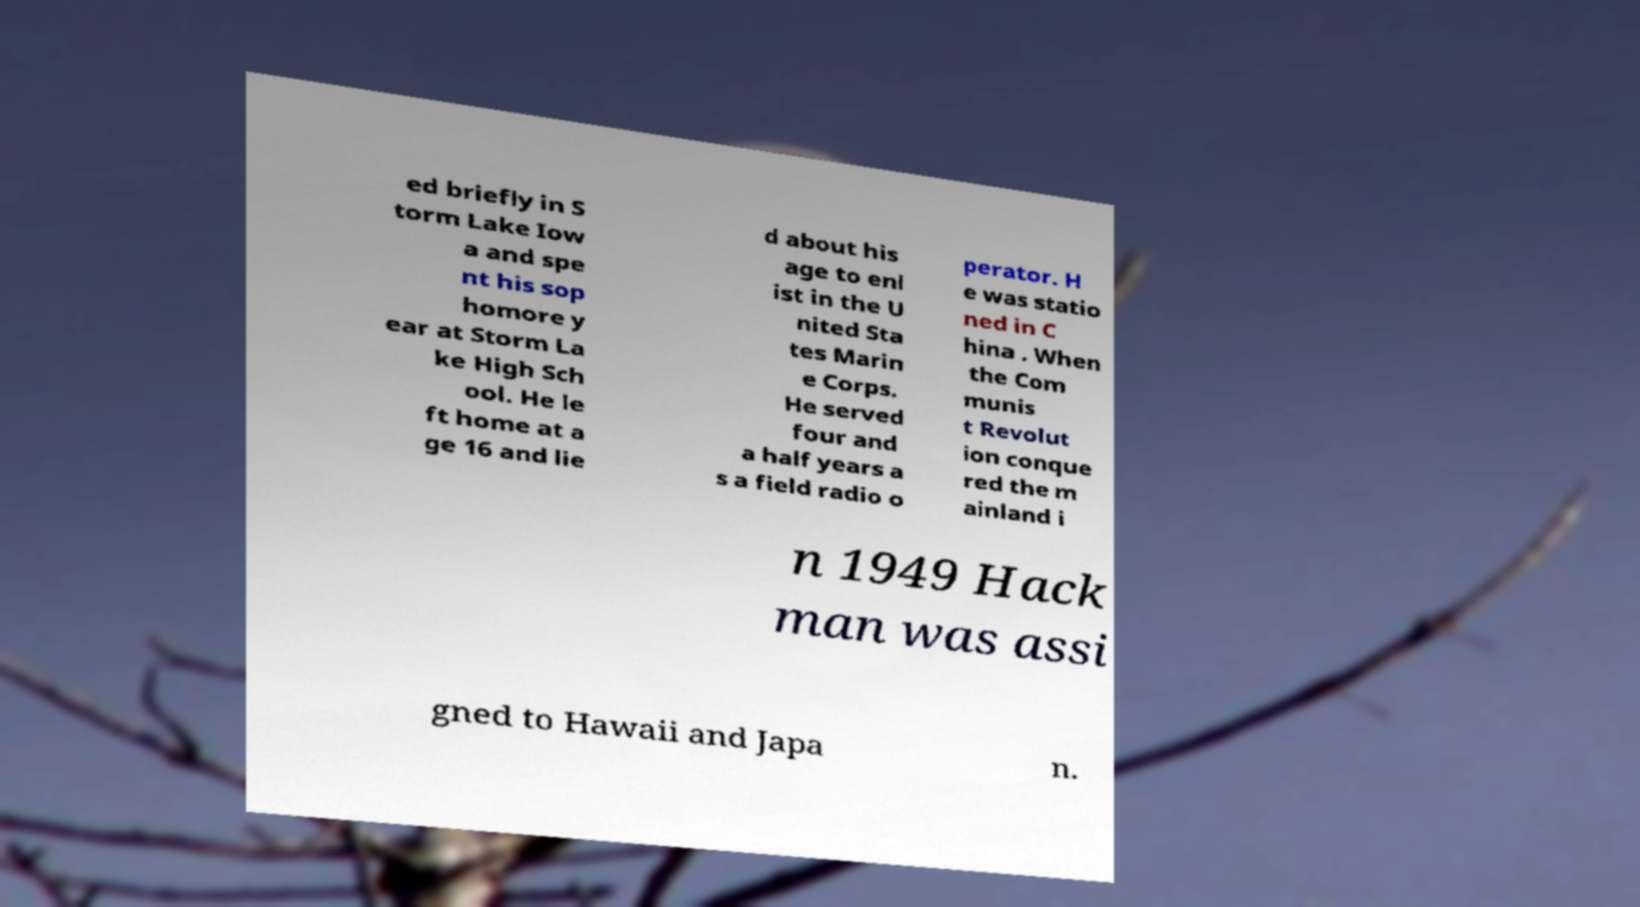Please read and relay the text visible in this image. What does it say? ed briefly in S torm Lake Iow a and spe nt his sop homore y ear at Storm La ke High Sch ool. He le ft home at a ge 16 and lie d about his age to enl ist in the U nited Sta tes Marin e Corps. He served four and a half years a s a field radio o perator. H e was statio ned in C hina . When the Com munis t Revolut ion conque red the m ainland i n 1949 Hack man was assi gned to Hawaii and Japa n. 